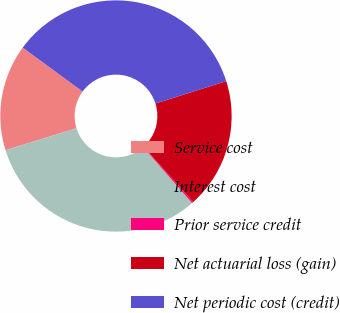Convert chart to OTSL. <chart><loc_0><loc_0><loc_500><loc_500><pie_chart><fcel>Service cost<fcel>Interest cost<fcel>Prior service credit<fcel>Net actuarial loss (gain)<fcel>Net periodic cost (credit)<nl><fcel>14.84%<fcel>31.66%<fcel>0.2%<fcel>18.24%<fcel>35.06%<nl></chart> 